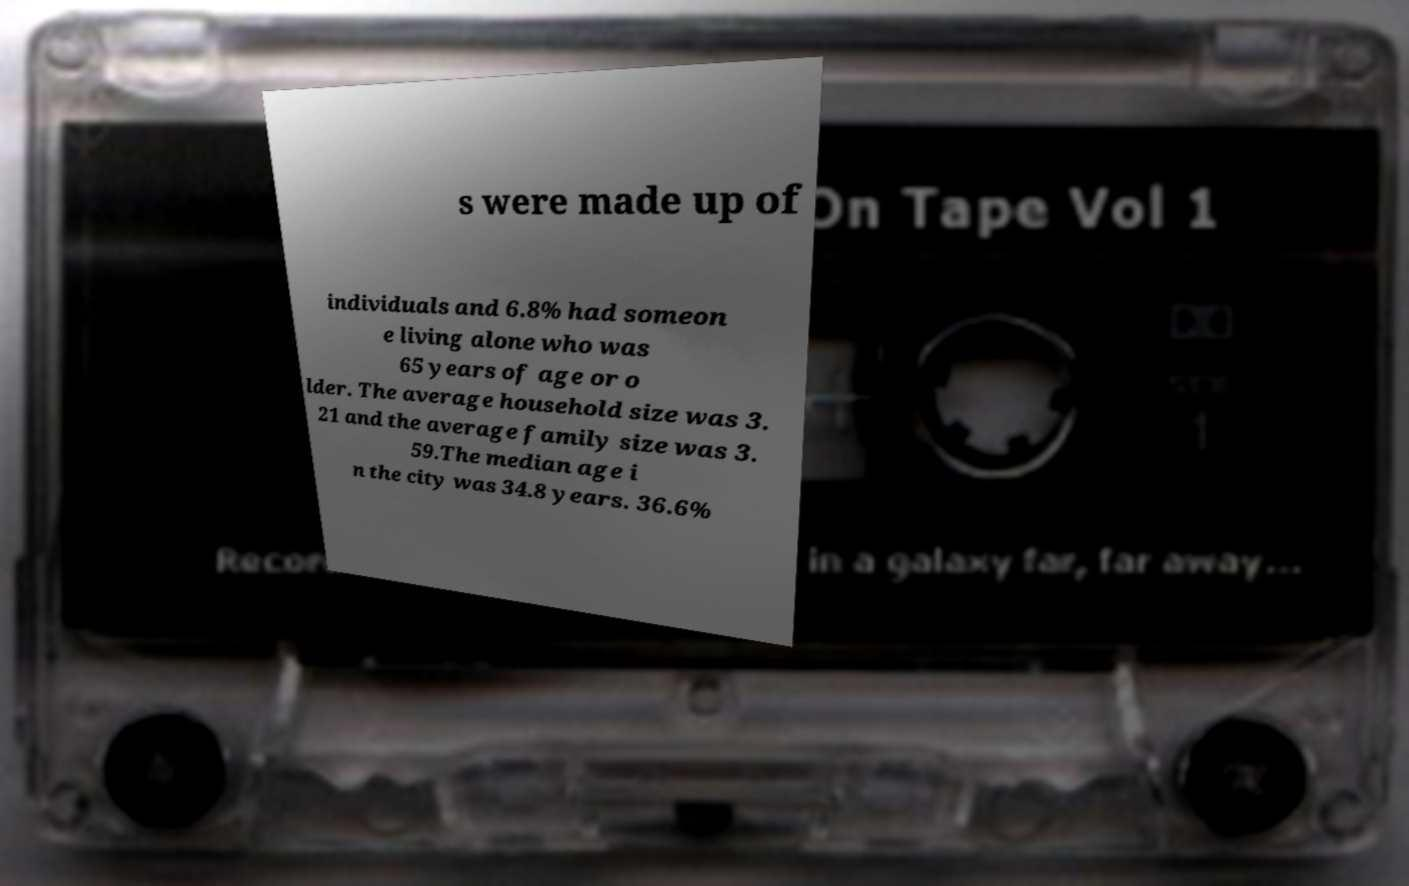Could you extract and type out the text from this image? s were made up of individuals and 6.8% had someon e living alone who was 65 years of age or o lder. The average household size was 3. 21 and the average family size was 3. 59.The median age i n the city was 34.8 years. 36.6% 